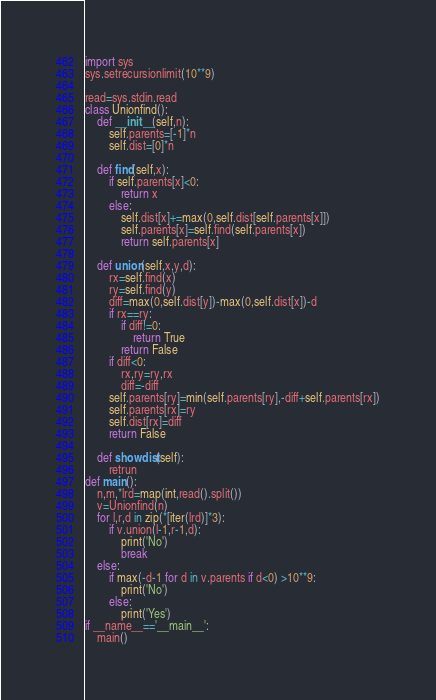<code> <loc_0><loc_0><loc_500><loc_500><_Python_>import sys
sys.setrecursionlimit(10**9)

read=sys.stdin.read
class Unionfind():
    def __init__(self,n):
        self.parents=[-1]*n
        self.dist=[0]*n 
    
    def find(self,x):
        if self.parents[x]<0:
            return x
        else:
            self.dist[x]+=max(0,self.dist[self.parents[x]])
            self.parents[x]=self.find(self.parents[x])
            return self.parents[x]
    
    def union(self,x,y,d):
        rx=self.find(x)
        ry=self.find(y)
        diff=max(0,self.dist[y])-max(0,self.dist[x])-d
        if rx==ry:
            if diff!=0:
                return True
            return False
        if diff<0:
            rx,ry=ry,rx
            diff=-diff
        self.parents[ry]=min(self.parents[ry],-diff+self.parents[rx])
        self.parents[rx]=ry
        self.dist[rx]=diff
        return False
    
    def showdist(self):
        retrun 
def main():
    n,m,*lrd=map(int,read().split())
    v=Unionfind(n)
    for l,r,d in zip(*[iter(lrd)]*3):
        if v.union(l-1,r-1,d):
            print('No')
            break
    else:
        if max(-d-1 for d in v.parents if d<0) >10**9:
            print('No')
        else:
            print('Yes')
if __name__=='__main__':
    main()
</code> 